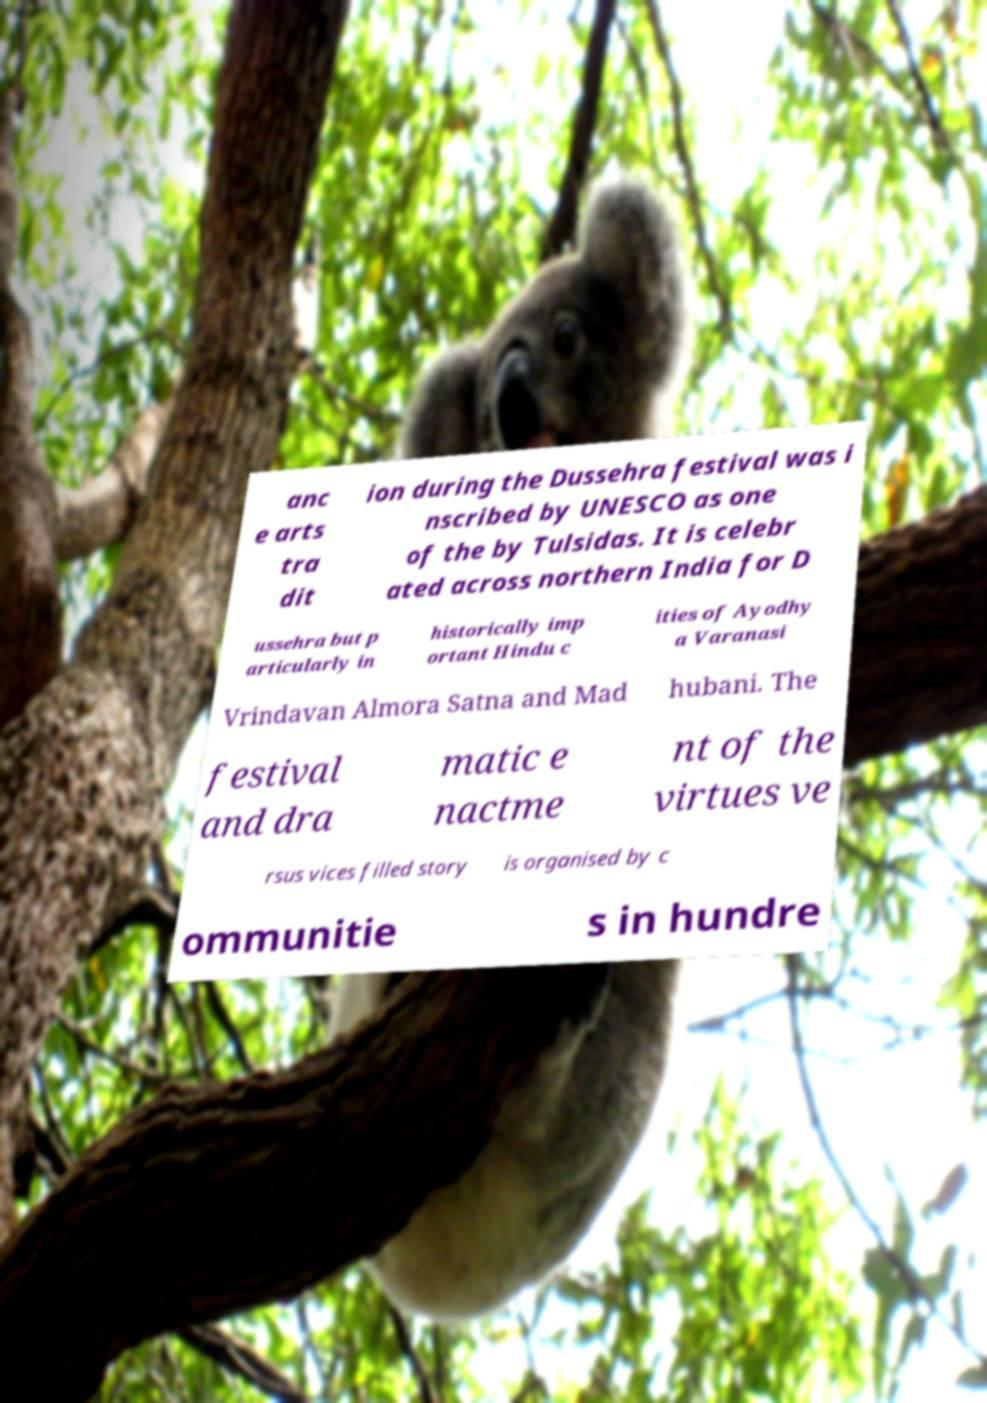Could you extract and type out the text from this image? anc e arts tra dit ion during the Dussehra festival was i nscribed by UNESCO as one of the by Tulsidas. It is celebr ated across northern India for D ussehra but p articularly in historically imp ortant Hindu c ities of Ayodhy a Varanasi Vrindavan Almora Satna and Mad hubani. The festival and dra matic e nactme nt of the virtues ve rsus vices filled story is organised by c ommunitie s in hundre 